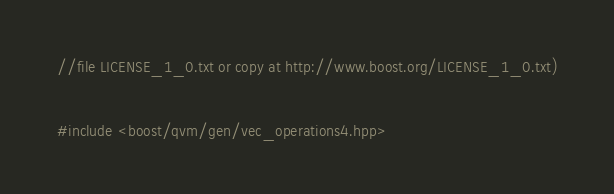Convert code to text. <code><loc_0><loc_0><loc_500><loc_500><_C++_>//file LICENSE_1_0.txt or copy at http://www.boost.org/LICENSE_1_0.txt)

#include <boost/qvm/gen/vec_operations4.hpp>
</code> 